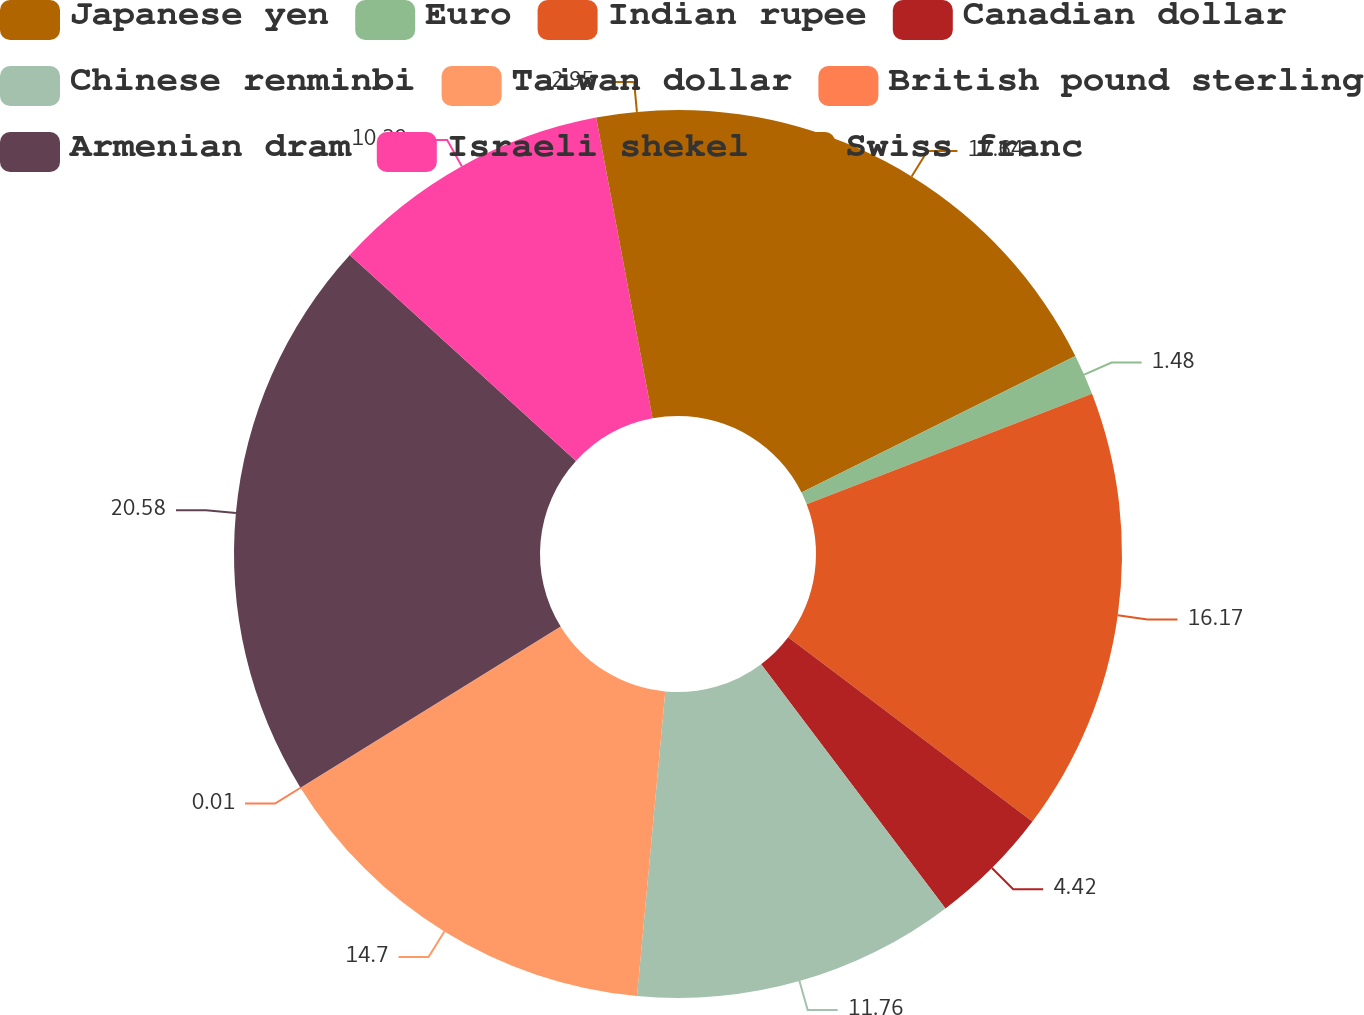Convert chart to OTSL. <chart><loc_0><loc_0><loc_500><loc_500><pie_chart><fcel>Japanese yen<fcel>Euro<fcel>Indian rupee<fcel>Canadian dollar<fcel>Chinese renminbi<fcel>Taiwan dollar<fcel>British pound sterling<fcel>Armenian dram<fcel>Israeli shekel<fcel>Swiss franc<nl><fcel>17.64%<fcel>1.48%<fcel>16.17%<fcel>4.42%<fcel>11.76%<fcel>14.7%<fcel>0.01%<fcel>20.58%<fcel>10.29%<fcel>2.95%<nl></chart> 